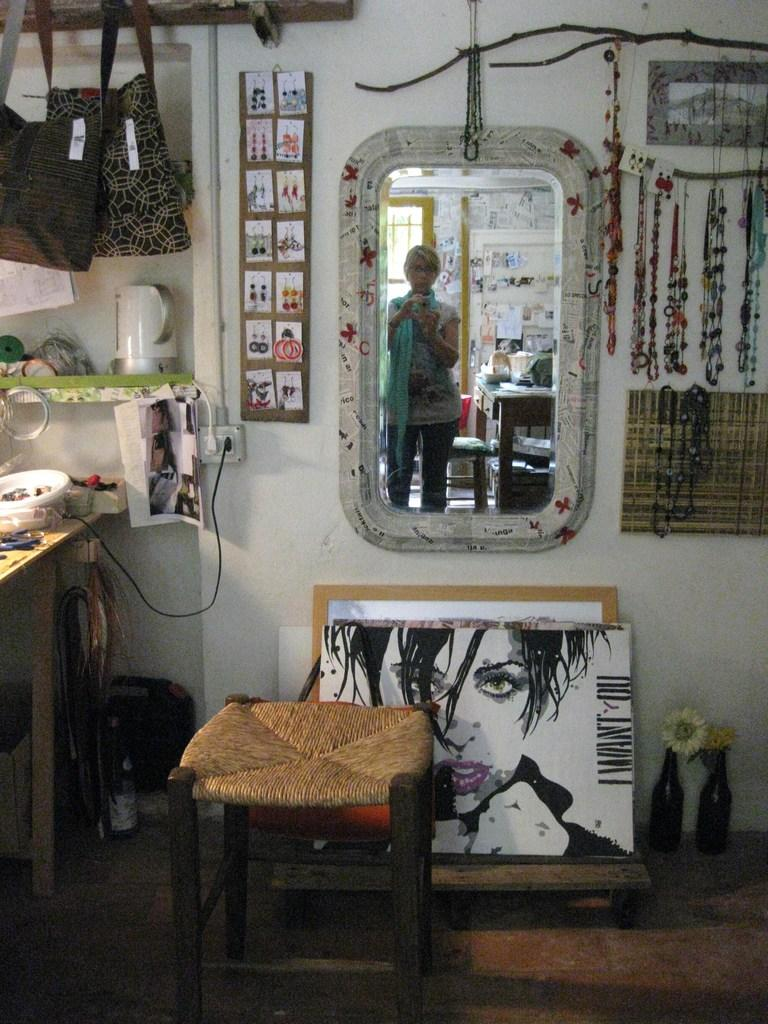What object is present in the image that allows for reflection? There is a mirror in the image. Who is standing in front of the mirror? A lady is standing in front of the mirror. What is the lady holding in the image? The lady is holding a camera. Where are the bags located in the image? The bags are in the left top corner of the image. What piece of furniture is in front of the mirror? There is a chair in front of the mirror. What type of zinc is present on the desk in the image? There is no desk or zinc present in the image. Can you describe the lady's jump in the image? There is no jump depicted in the image; the lady is standing in front of the mirror. 